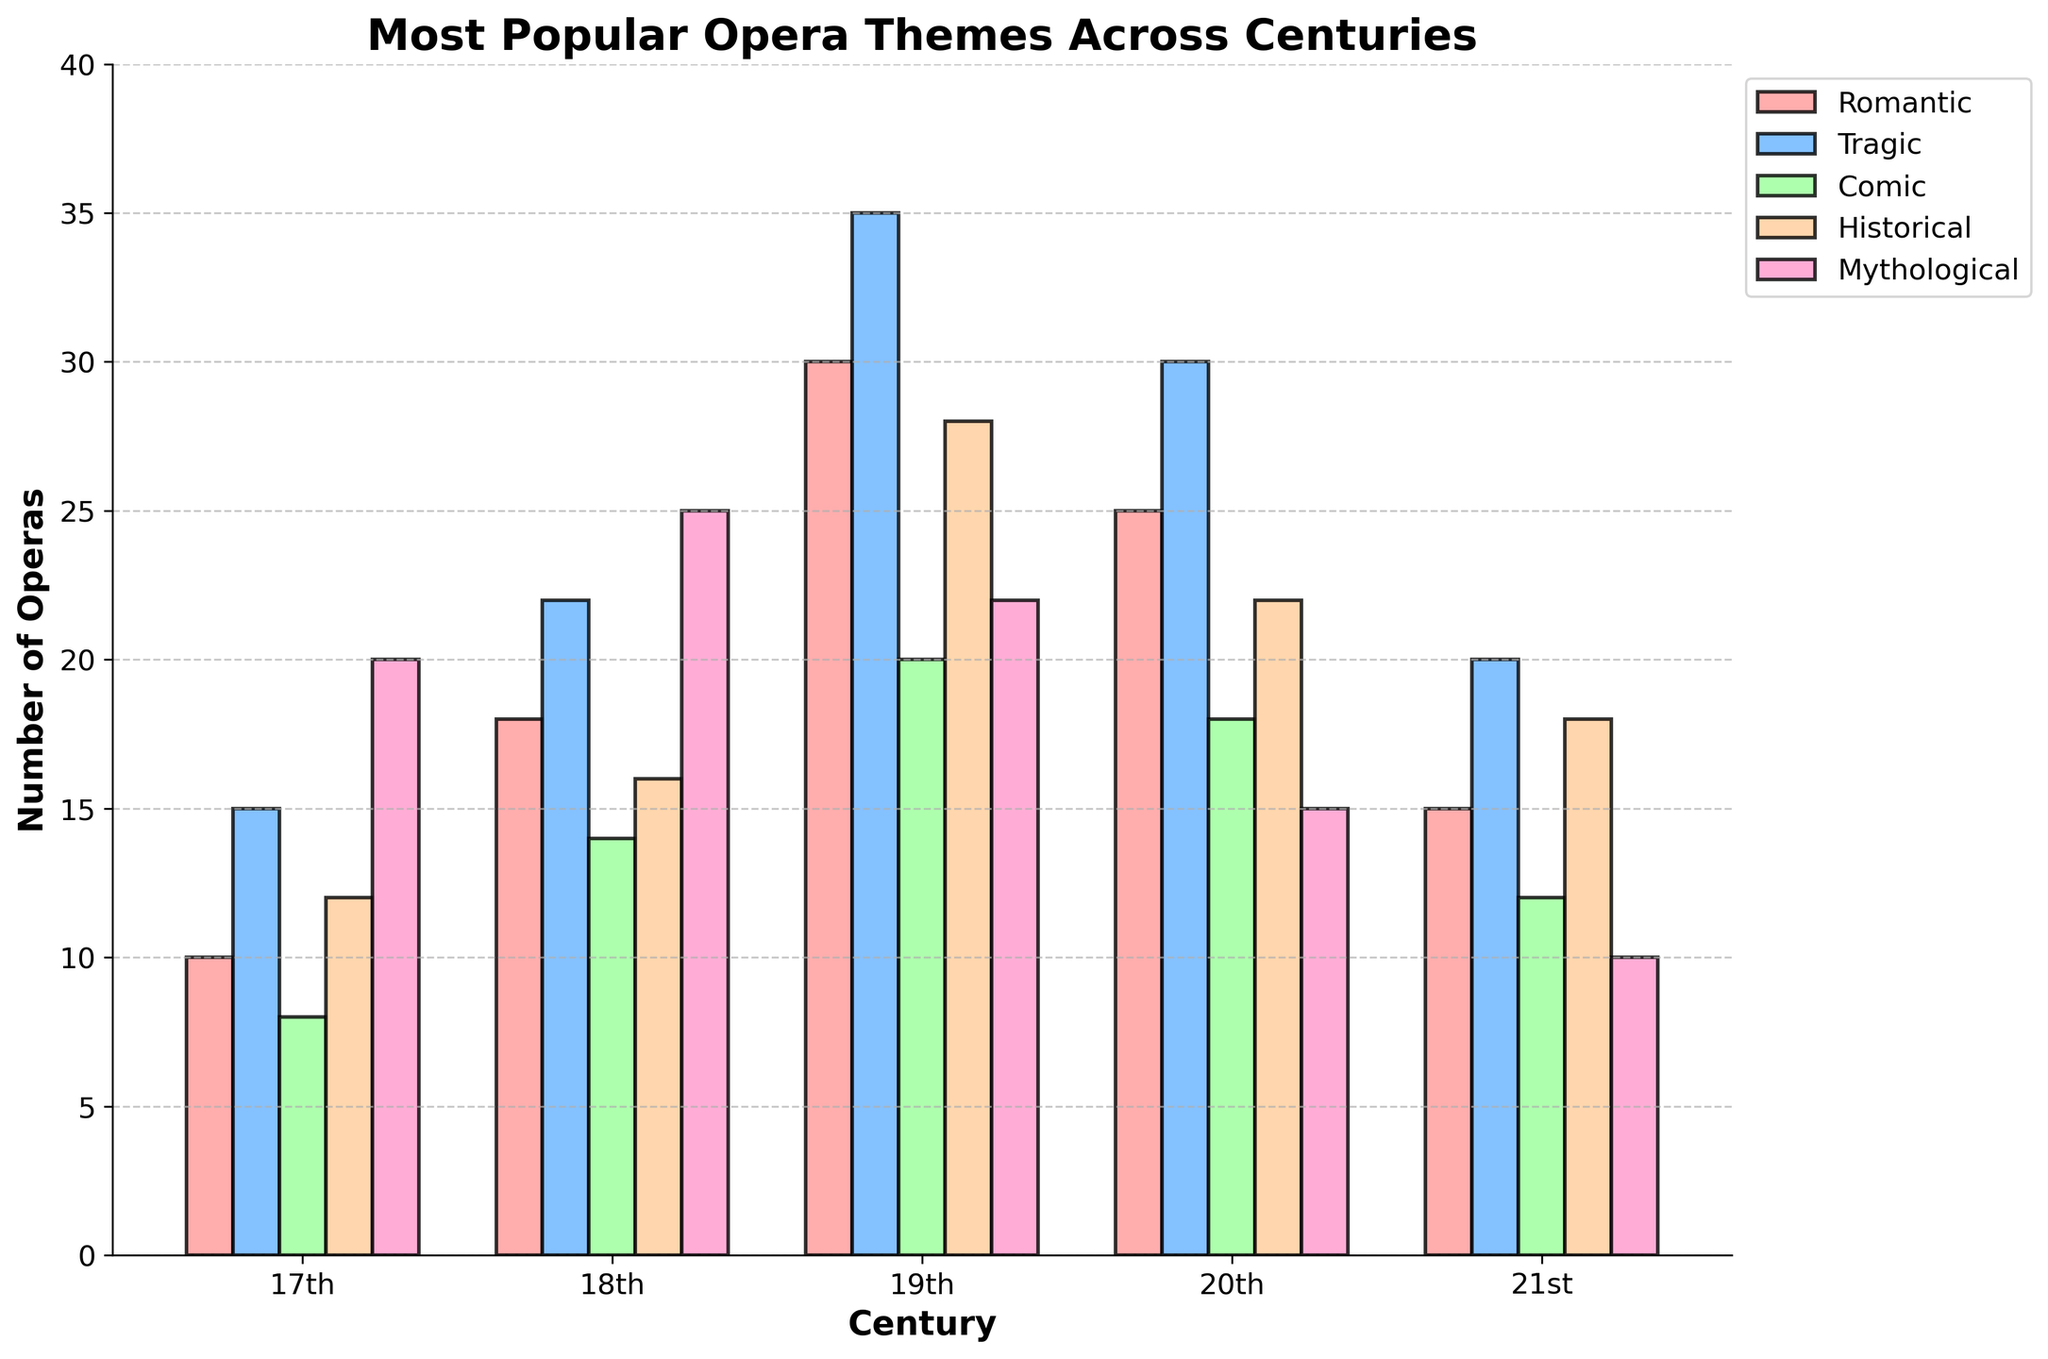What's the most popular opera theme in the 19th century? The tallest bar for the 19th century represents the most popular theme. For the 19th century, the highest bar is for the Tragic theme.
Answer: Tragic Which century has the fewest Comic operas? The shortest bar in the Comic category across all centuries shows the century with the fewest Comic operas. In this case, the 17th century has the shortest Comic bar.
Answer: 17th What's the combined number of Romantic and Mythological operas in the 20th century? Find the bars for the Romantic and Mythological themes in the 20th century and add their heights. Romantic has 25 and Mythological has 15, so 25 + 15 = 40.
Answer: 40 How many more Tragic operas than Comic operas were there in the 18th century? Subtract the number of Comic operas from the number of Tragic operas in the 18th century. Tragic has 22 and Comic has 14, so 22 - 14 = 8.
Answer: 8 Which theme had a decreasing trend over the centuries? Look at the heights of bars for each theme across centuries and identify the one that continuously decreases. The Mythological theme shows this trend with 20 in the 17th century reducing consistently to 10 in the 21st century.
Answer: Mythological What is the average number of Historical operas per century? Add the number of Historical operas for each century, then divide by the total number of centuries. (12 + 16 + 28 + 22 + 18) / 5 = 19.2.
Answer: 19.2 Between Romantic and Comic operas in the 21st century, which is more popular and by how much? Compare the heights of Romantic and Comic bars in the 21st century. Romantic has 15 and Comic has 12, the difference is 15 - 12 = 3.
Answer: Romantic, by 3 In which century was the total number of operas across all themes the highest? Add up the heights of bars for all themes in each century and compare. The 19th century has the highest total: 30 + 35 + 20 + 28 + 22 = 135.
Answer: 19th Which color represents the Historical theme, and how can you identify it? Look at the legend to find the color associated with Historical. The Historical theme is represented by a bar with a brownish color.
Answer: Brown Are there any centuries where the number of Romantic operas exceeds the number of Tragic operas? Compare the heights of Romantic and Tragic bars for each century. In the data set provided, Tragic operas consistently outnumber Romantic operas in every century.
Answer: No 